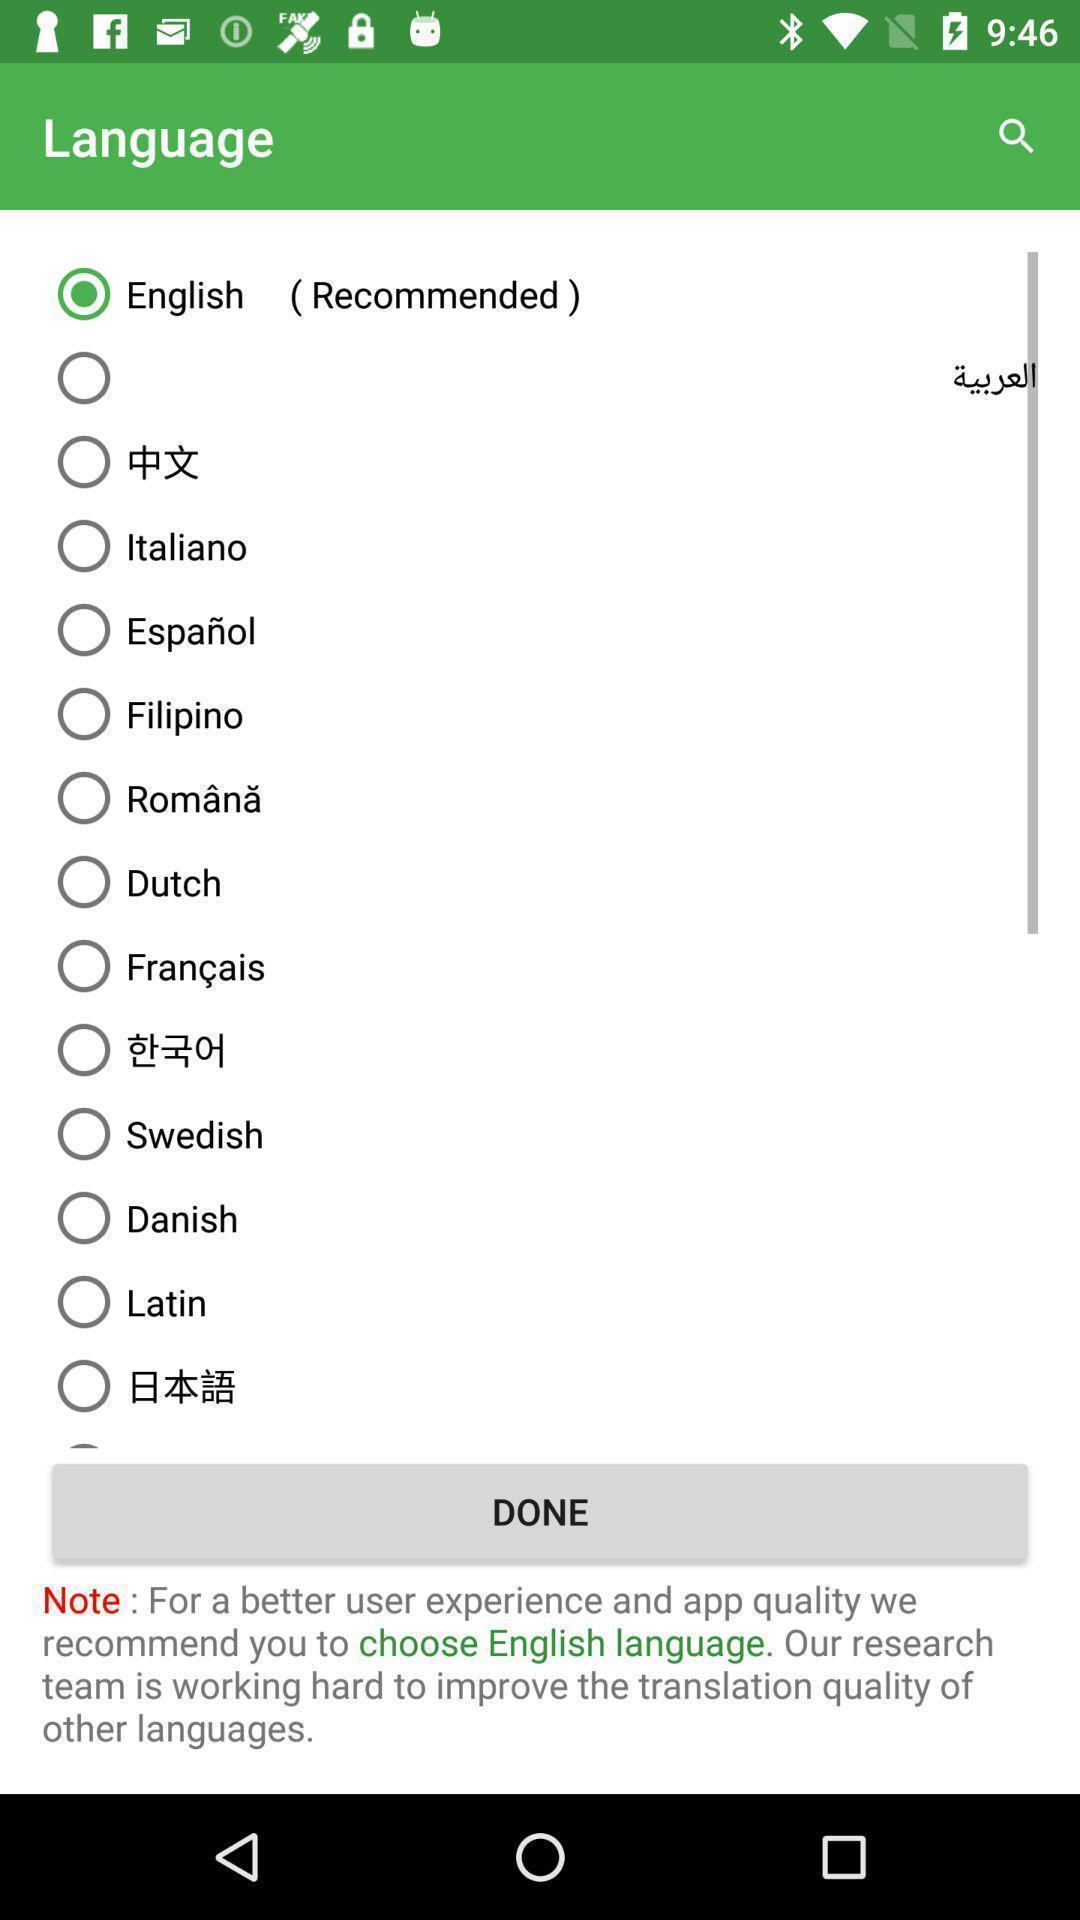Describe this image in words. Various language list displayed. 